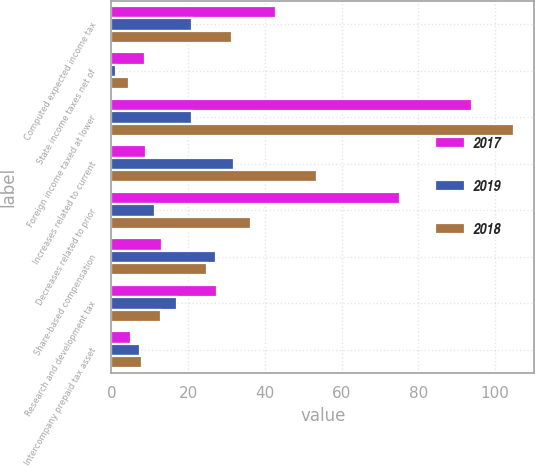<chart> <loc_0><loc_0><loc_500><loc_500><stacked_bar_chart><ecel><fcel>Computed expected income tax<fcel>State income taxes net of<fcel>Foreign income taxed at lower<fcel>Increases related to current<fcel>Decreases related to prior<fcel>Share-based compensation<fcel>Research and development tax<fcel>Intercompany prepaid tax asset<nl><fcel>2017<fcel>43<fcel>8.7<fcel>94<fcel>9<fcel>75.1<fcel>13.3<fcel>27.5<fcel>5.2<nl><fcel>2019<fcel>21<fcel>1.3<fcel>21<fcel>32<fcel>11.3<fcel>27.2<fcel>17<fcel>7.4<nl><fcel>2018<fcel>31.4<fcel>4.6<fcel>105<fcel>53.7<fcel>36.3<fcel>25<fcel>12.8<fcel>7.9<nl></chart> 